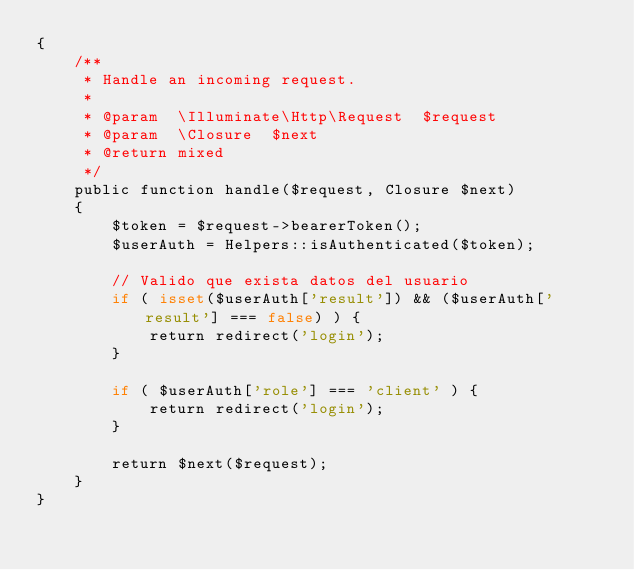<code> <loc_0><loc_0><loc_500><loc_500><_PHP_>{
    /**
     * Handle an incoming request.
     *
     * @param  \Illuminate\Http\Request  $request
     * @param  \Closure  $next
     * @return mixed
     */
    public function handle($request, Closure $next)
    {
        $token = $request->bearerToken();
        $userAuth = Helpers::isAuthenticated($token);

        // Valido que exista datos del usuario
        if ( isset($userAuth['result']) && ($userAuth['result'] === false) ) {
            return redirect('login');
        }

        if ( $userAuth['role'] === 'client' ) {
            return redirect('login');
        }

        return $next($request);
    }
}
</code> 